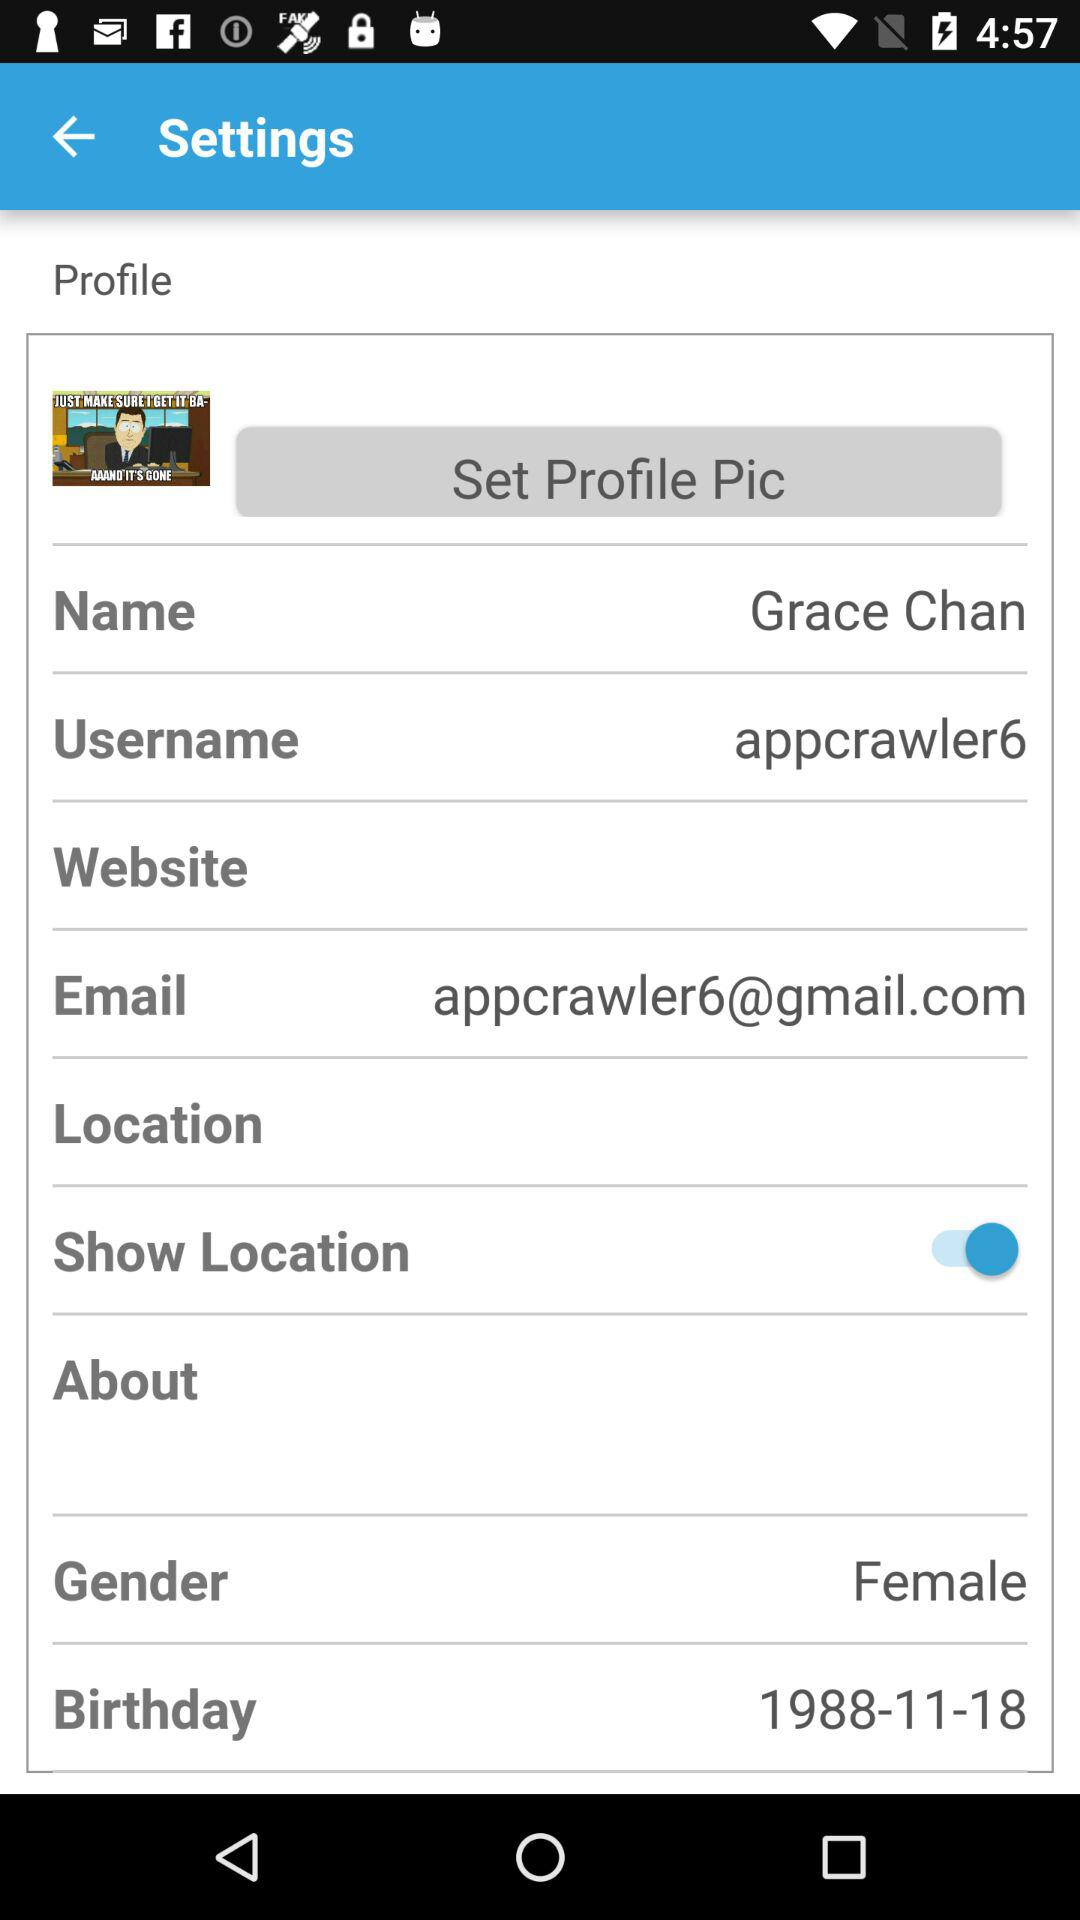What is the status of "Show Location"? The status is "on". 